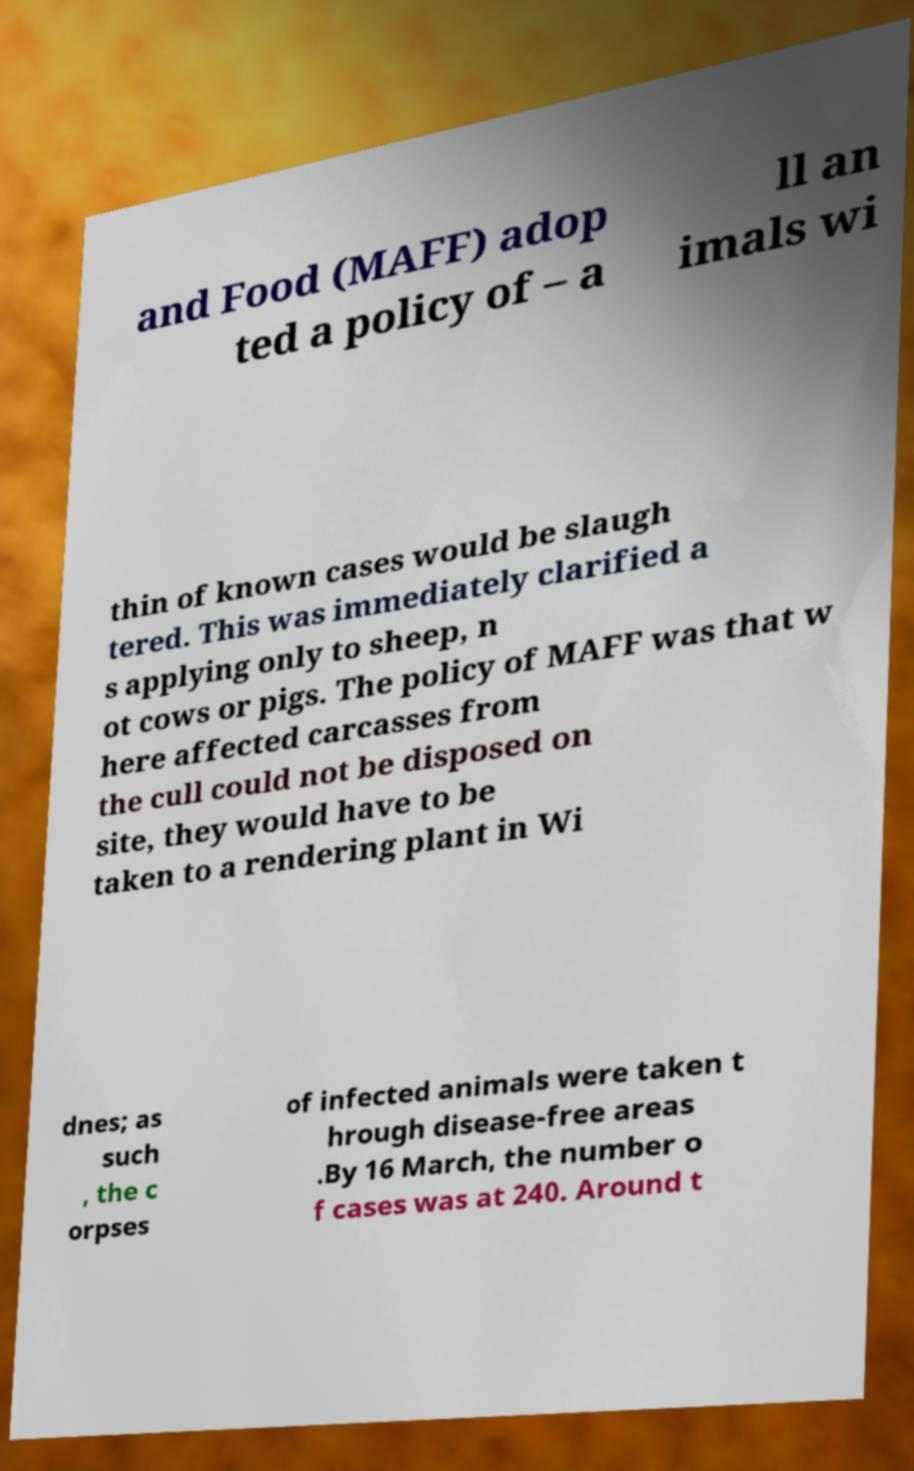For documentation purposes, I need the text within this image transcribed. Could you provide that? and Food (MAFF) adop ted a policy of – a ll an imals wi thin of known cases would be slaugh tered. This was immediately clarified a s applying only to sheep, n ot cows or pigs. The policy of MAFF was that w here affected carcasses from the cull could not be disposed on site, they would have to be taken to a rendering plant in Wi dnes; as such , the c orpses of infected animals were taken t hrough disease-free areas .By 16 March, the number o f cases was at 240. Around t 